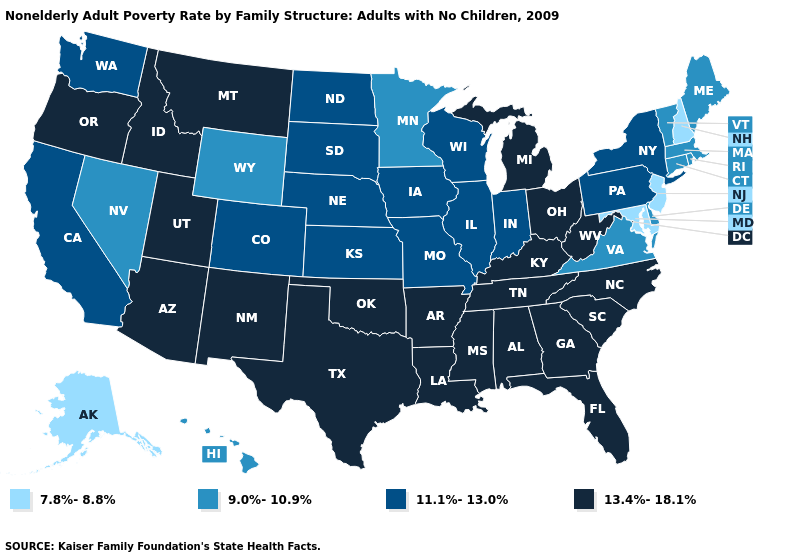Among the states that border Florida , which have the lowest value?
Short answer required. Alabama, Georgia. What is the lowest value in states that border Kentucky?
Answer briefly. 9.0%-10.9%. Name the states that have a value in the range 7.8%-8.8%?
Keep it brief. Alaska, Maryland, New Hampshire, New Jersey. What is the lowest value in states that border Wyoming?
Be succinct. 11.1%-13.0%. Name the states that have a value in the range 11.1%-13.0%?
Give a very brief answer. California, Colorado, Illinois, Indiana, Iowa, Kansas, Missouri, Nebraska, New York, North Dakota, Pennsylvania, South Dakota, Washington, Wisconsin. Does Illinois have the highest value in the USA?
Keep it brief. No. What is the value of West Virginia?
Be succinct. 13.4%-18.1%. Name the states that have a value in the range 9.0%-10.9%?
Quick response, please. Connecticut, Delaware, Hawaii, Maine, Massachusetts, Minnesota, Nevada, Rhode Island, Vermont, Virginia, Wyoming. Name the states that have a value in the range 11.1%-13.0%?
Short answer required. California, Colorado, Illinois, Indiana, Iowa, Kansas, Missouri, Nebraska, New York, North Dakota, Pennsylvania, South Dakota, Washington, Wisconsin. Name the states that have a value in the range 11.1%-13.0%?
Concise answer only. California, Colorado, Illinois, Indiana, Iowa, Kansas, Missouri, Nebraska, New York, North Dakota, Pennsylvania, South Dakota, Washington, Wisconsin. Among the states that border North Dakota , which have the lowest value?
Keep it brief. Minnesota. What is the highest value in states that border Kansas?
Concise answer only. 13.4%-18.1%. What is the highest value in states that border Illinois?
Answer briefly. 13.4%-18.1%. Name the states that have a value in the range 7.8%-8.8%?
Keep it brief. Alaska, Maryland, New Hampshire, New Jersey. Name the states that have a value in the range 7.8%-8.8%?
Give a very brief answer. Alaska, Maryland, New Hampshire, New Jersey. 